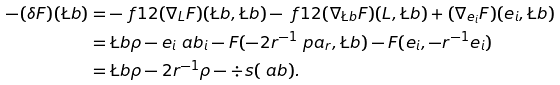Convert formula to latex. <formula><loc_0><loc_0><loc_500><loc_500>- ( \delta F ) ( \L b ) & = - \ f 1 2 ( \nabla _ { L } F ) ( \L b , \L b ) - \ f 1 2 ( \nabla _ { \L b } F ) ( L , \L b ) + ( \nabla _ { e _ { i } } F ) ( e _ { i } , \L b ) \\ & = \L b \rho - e _ { i } \ a b _ { i } - F ( - 2 r ^ { - 1 } \ p a _ { r } , \L b ) - F ( e _ { i } , - r ^ { - 1 } e _ { i } ) \\ & = \L b \rho - 2 r ^ { - 1 } \rho - \div s ( \ a b ) .</formula> 